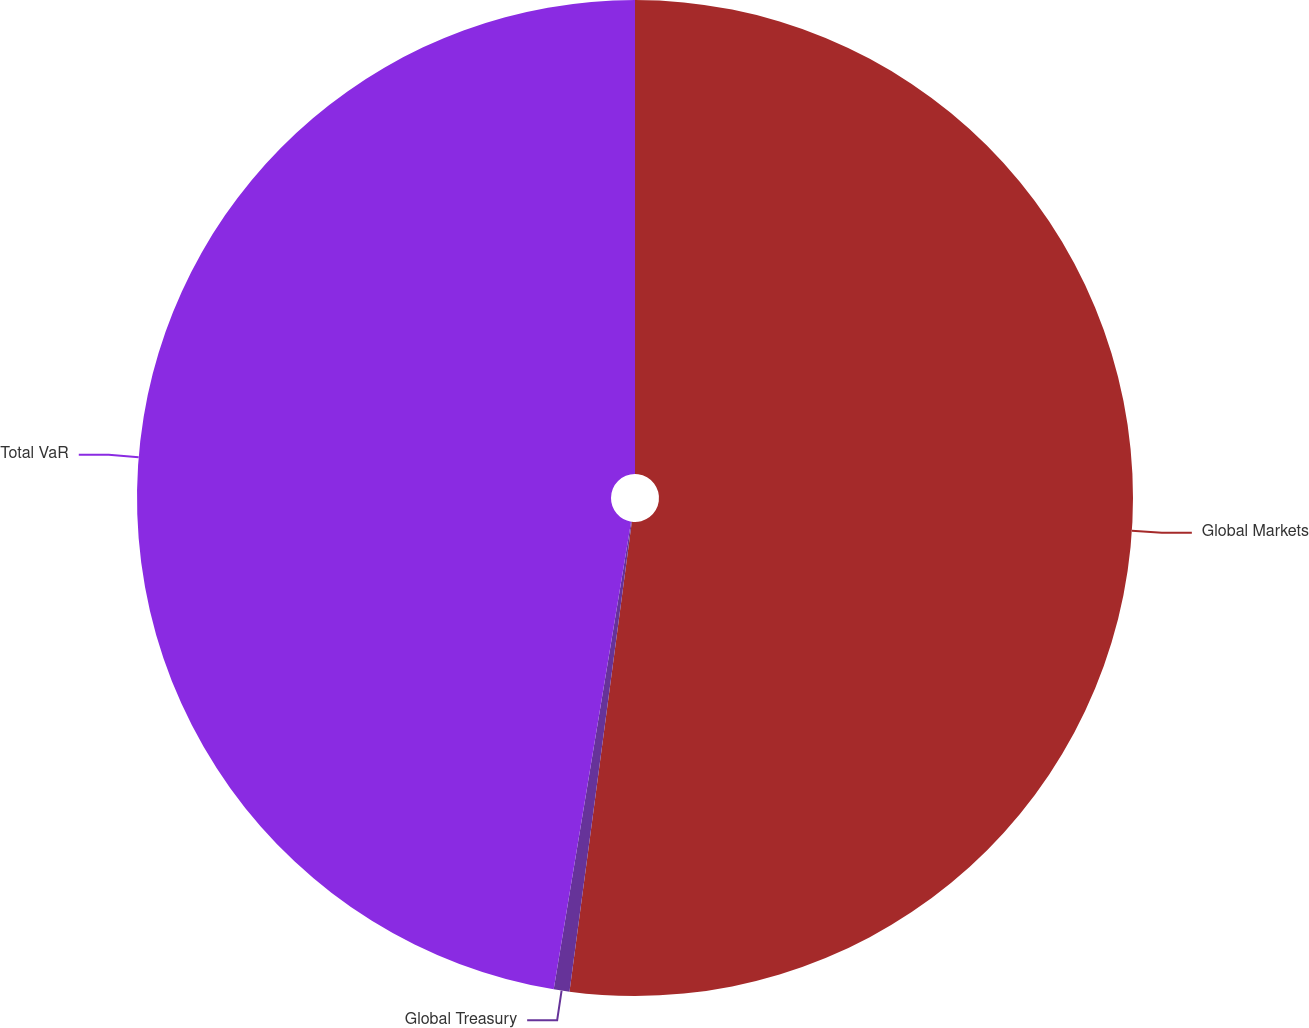Convert chart to OTSL. <chart><loc_0><loc_0><loc_500><loc_500><pie_chart><fcel>Global Markets<fcel>Global Treasury<fcel>Total VaR<nl><fcel>52.1%<fcel>0.51%<fcel>47.39%<nl></chart> 